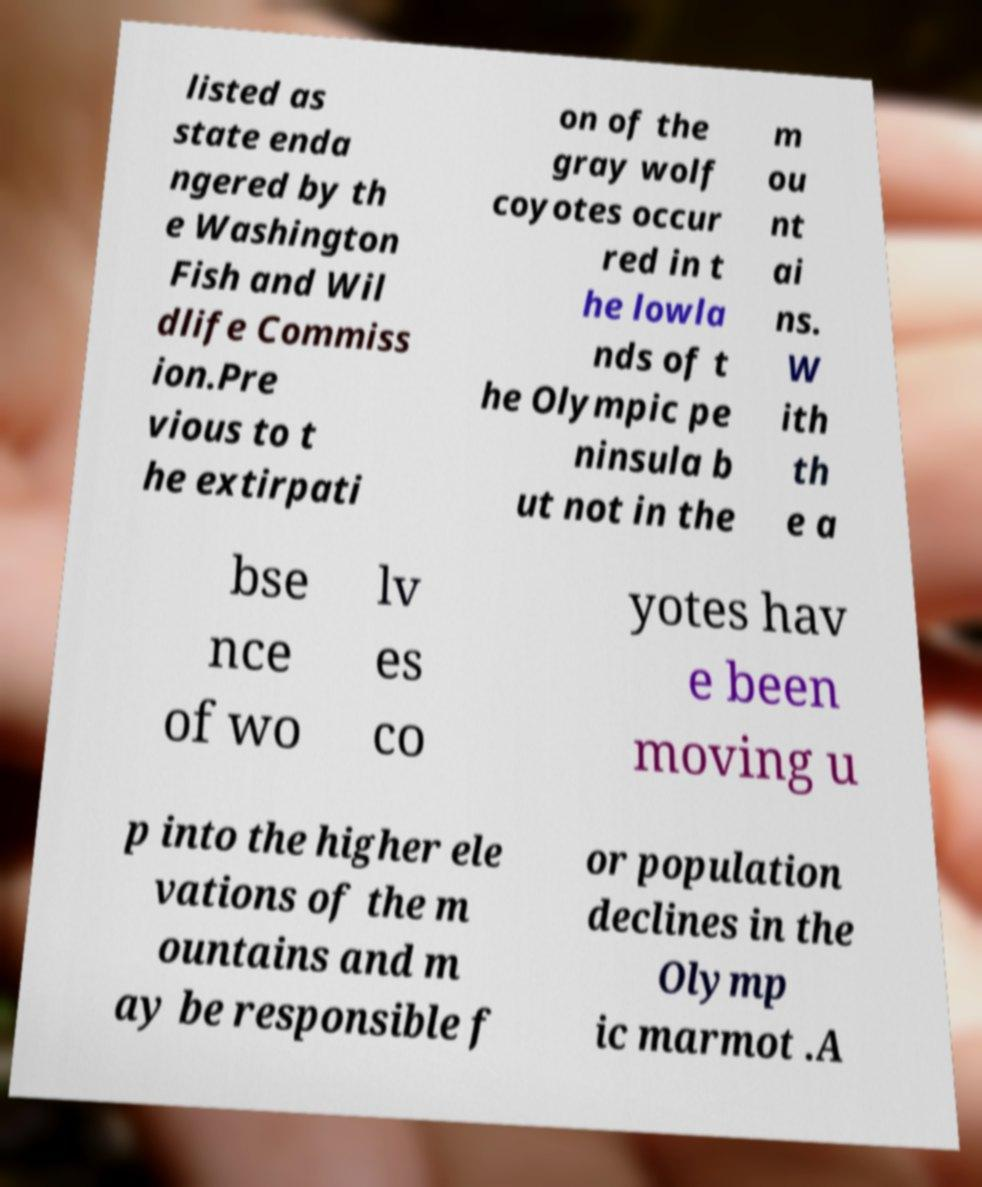Please identify and transcribe the text found in this image. listed as state enda ngered by th e Washington Fish and Wil dlife Commiss ion.Pre vious to t he extirpati on of the gray wolf coyotes occur red in t he lowla nds of t he Olympic pe ninsula b ut not in the m ou nt ai ns. W ith th e a bse nce of wo lv es co yotes hav e been moving u p into the higher ele vations of the m ountains and m ay be responsible f or population declines in the Olymp ic marmot .A 